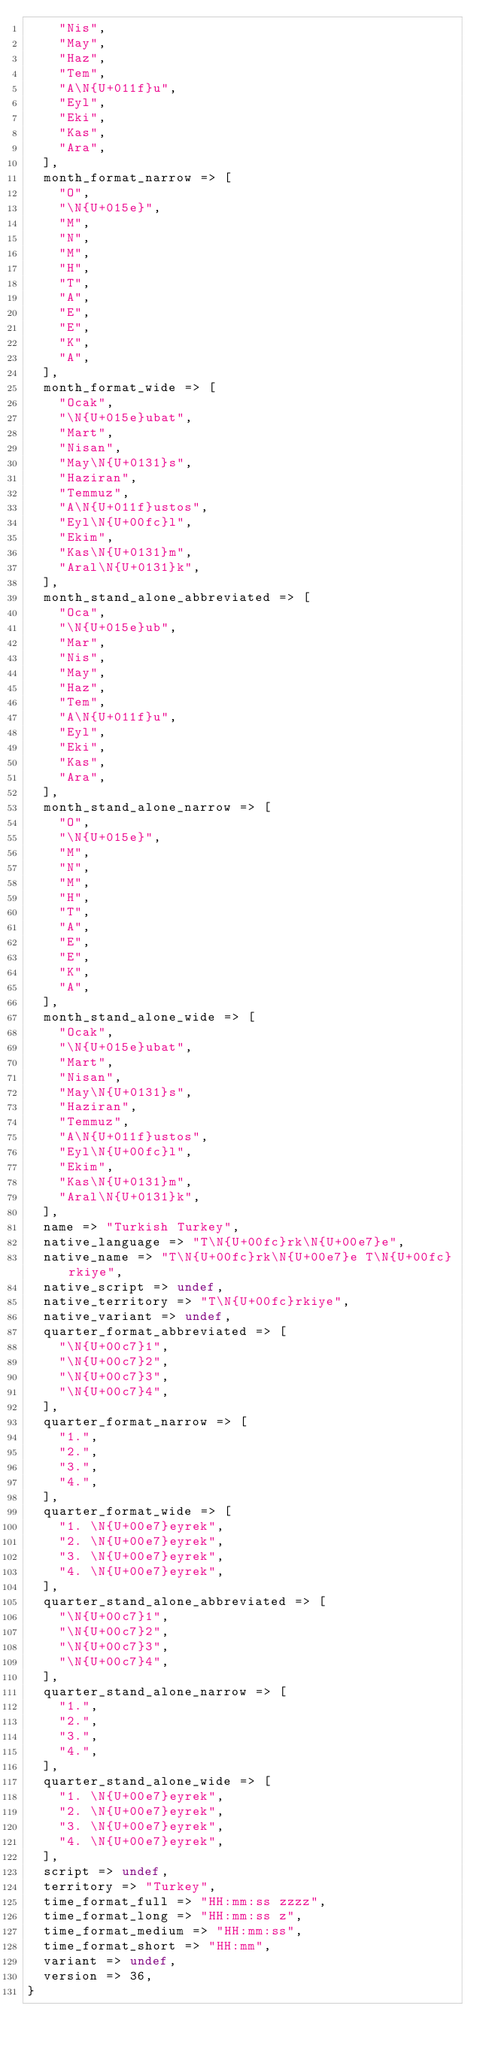<code> <loc_0><loc_0><loc_500><loc_500><_Perl_>    "Nis",
    "May",
    "Haz",
    "Tem",
    "A\N{U+011f}u",
    "Eyl",
    "Eki",
    "Kas",
    "Ara",
  ],
  month_format_narrow => [
    "O",
    "\N{U+015e}",
    "M",
    "N",
    "M",
    "H",
    "T",
    "A",
    "E",
    "E",
    "K",
    "A",
  ],
  month_format_wide => [
    "Ocak",
    "\N{U+015e}ubat",
    "Mart",
    "Nisan",
    "May\N{U+0131}s",
    "Haziran",
    "Temmuz",
    "A\N{U+011f}ustos",
    "Eyl\N{U+00fc}l",
    "Ekim",
    "Kas\N{U+0131}m",
    "Aral\N{U+0131}k",
  ],
  month_stand_alone_abbreviated => [
    "Oca",
    "\N{U+015e}ub",
    "Mar",
    "Nis",
    "May",
    "Haz",
    "Tem",
    "A\N{U+011f}u",
    "Eyl",
    "Eki",
    "Kas",
    "Ara",
  ],
  month_stand_alone_narrow => [
    "O",
    "\N{U+015e}",
    "M",
    "N",
    "M",
    "H",
    "T",
    "A",
    "E",
    "E",
    "K",
    "A",
  ],
  month_stand_alone_wide => [
    "Ocak",
    "\N{U+015e}ubat",
    "Mart",
    "Nisan",
    "May\N{U+0131}s",
    "Haziran",
    "Temmuz",
    "A\N{U+011f}ustos",
    "Eyl\N{U+00fc}l",
    "Ekim",
    "Kas\N{U+0131}m",
    "Aral\N{U+0131}k",
  ],
  name => "Turkish Turkey",
  native_language => "T\N{U+00fc}rk\N{U+00e7}e",
  native_name => "T\N{U+00fc}rk\N{U+00e7}e T\N{U+00fc}rkiye",
  native_script => undef,
  native_territory => "T\N{U+00fc}rkiye",
  native_variant => undef,
  quarter_format_abbreviated => [
    "\N{U+00c7}1",
    "\N{U+00c7}2",
    "\N{U+00c7}3",
    "\N{U+00c7}4",
  ],
  quarter_format_narrow => [
    "1.",
    "2.",
    "3.",
    "4.",
  ],
  quarter_format_wide => [
    "1. \N{U+00e7}eyrek",
    "2. \N{U+00e7}eyrek",
    "3. \N{U+00e7}eyrek",
    "4. \N{U+00e7}eyrek",
  ],
  quarter_stand_alone_abbreviated => [
    "\N{U+00c7}1",
    "\N{U+00c7}2",
    "\N{U+00c7}3",
    "\N{U+00c7}4",
  ],
  quarter_stand_alone_narrow => [
    "1.",
    "2.",
    "3.",
    "4.",
  ],
  quarter_stand_alone_wide => [
    "1. \N{U+00e7}eyrek",
    "2. \N{U+00e7}eyrek",
    "3. \N{U+00e7}eyrek",
    "4. \N{U+00e7}eyrek",
  ],
  script => undef,
  territory => "Turkey",
  time_format_full => "HH:mm:ss zzzz",
  time_format_long => "HH:mm:ss z",
  time_format_medium => "HH:mm:ss",
  time_format_short => "HH:mm",
  variant => undef,
  version => 36,
}
</code> 